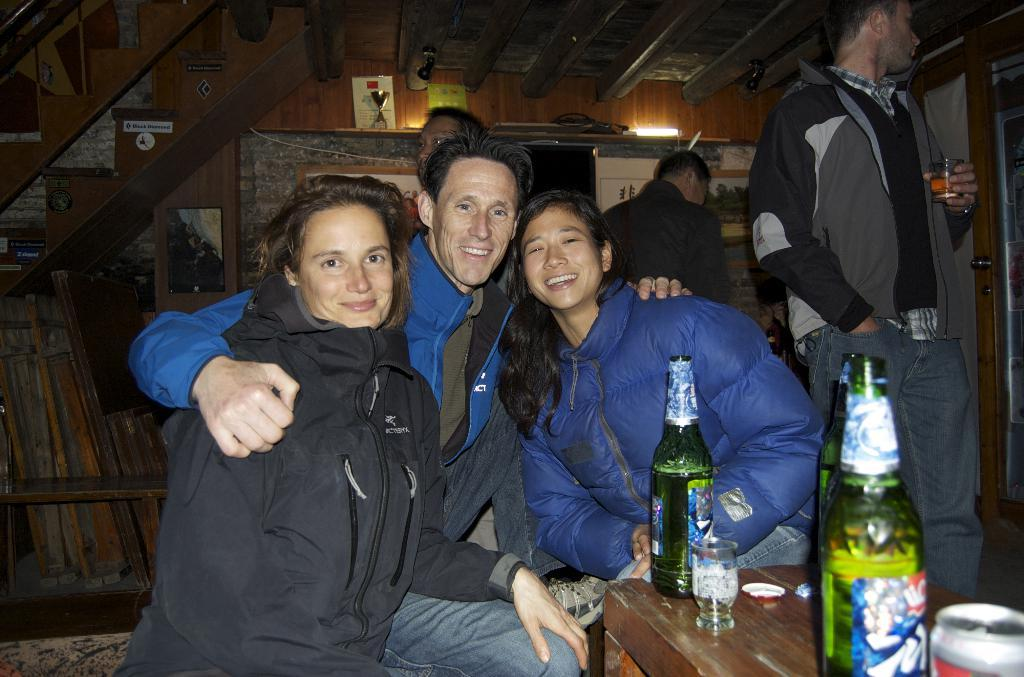What are the people in the image doing? The people in the image are standing and sitting. What can be seen on the right side of the image? There is a table on the right side of the image. What items are on the table? There are glasses and bottles on the table. What type of rice is being served in the prison in the image? There is no rice or prison present in the image. 